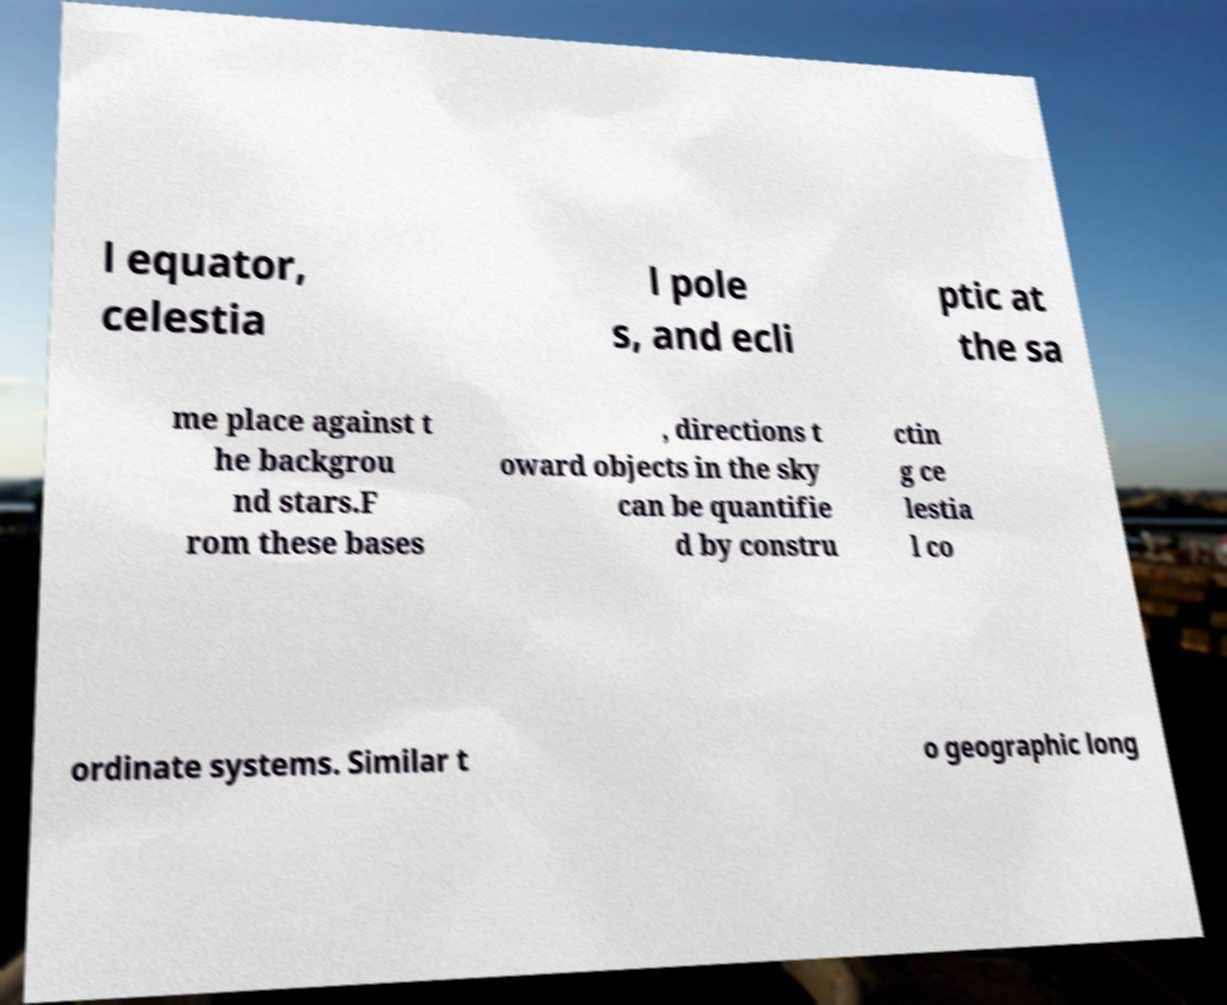Could you assist in decoding the text presented in this image and type it out clearly? l equator, celestia l pole s, and ecli ptic at the sa me place against t he backgrou nd stars.F rom these bases , directions t oward objects in the sky can be quantifie d by constru ctin g ce lestia l co ordinate systems. Similar t o geographic long 